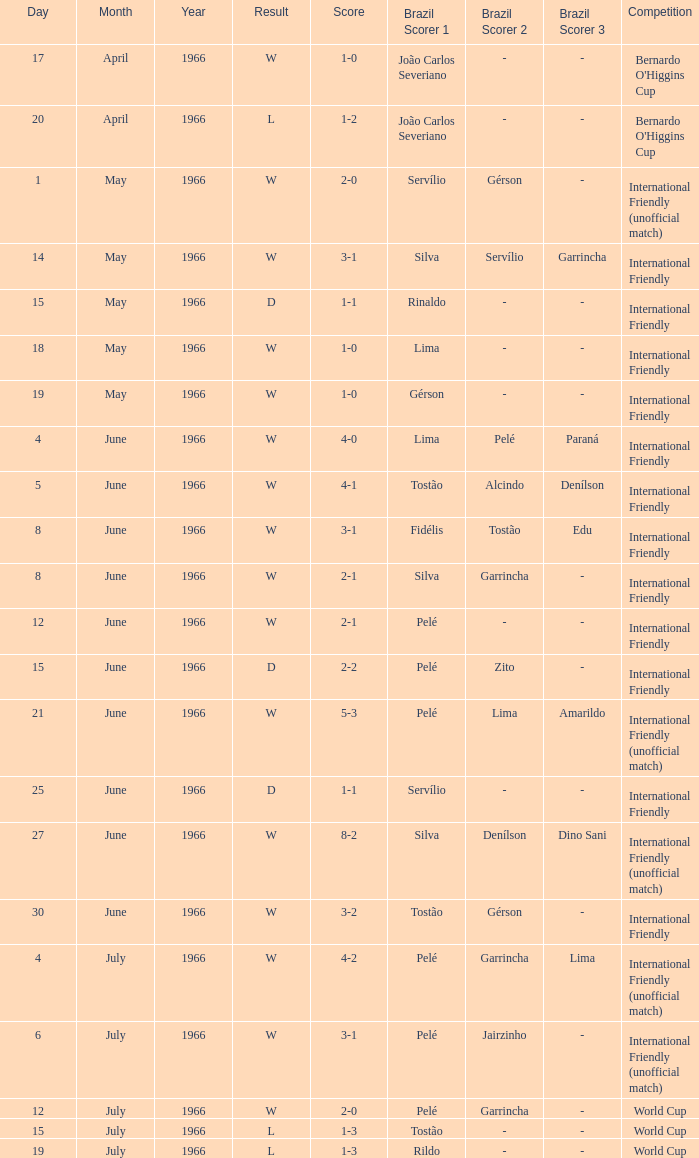What is the outcome of the international friendly competition on may 15, 1966? D. 